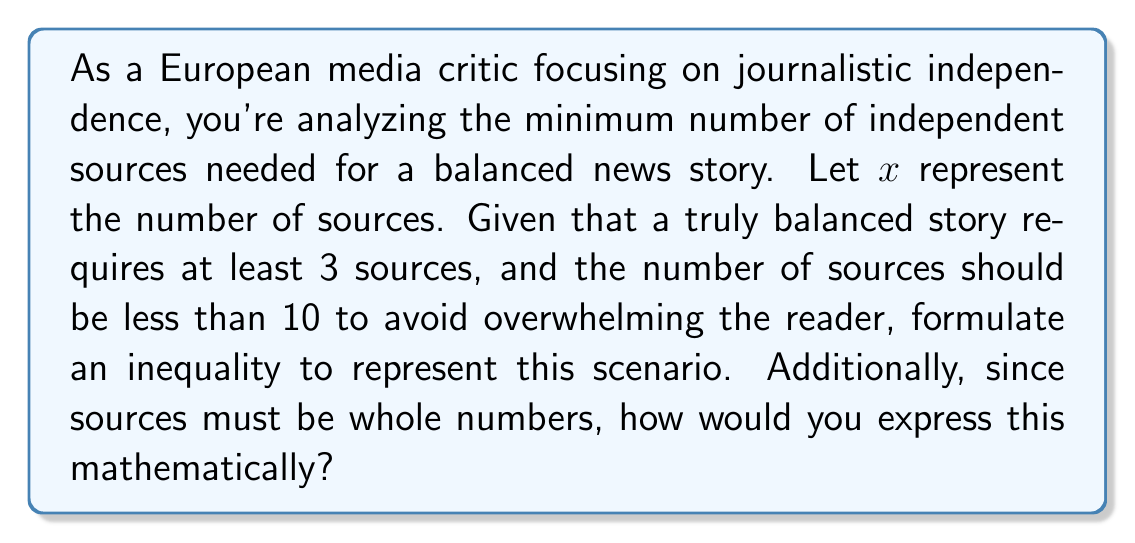Help me with this question. To solve this problem, we need to break it down into steps:

1. Establish the lower bound:
   The question states that a balanced story requires at least 3 sources. This can be expressed as:
   $$x \geq 3$$

2. Establish the upper bound:
   The number of sources should be less than 10 to avoid overwhelming the reader. This can be expressed as:
   $$x < 10$$

3. Combine the inequalities:
   We can express both conditions in a single compound inequality:
   $$3 \leq x < 10$$

4. Consider the whole number requirement:
   Since sources must be whole numbers, we need to use the floor and ceiling functions to express this. The floor function $\lfloor x \rfloor$ gives the largest integer less than or equal to $x$, while the ceiling function $\lceil x \rceil$ gives the smallest integer greater than or equal to $x$.

   We can express the whole number requirement as:
   $$x = \lfloor x \rfloor = \lceil x \rceil$$

5. Combine all conditions:
   The final inequality, incorporating all conditions, can be expressed as:
   $$3 \leq x < 10 \text{ and } x = \lfloor x \rfloor = \lceil x \rceil$$

This inequality represents the minimum number of independent sources needed for a balanced news story, ensuring journalistic independence while not overwhelming the reader, and accounting for the fact that sources must be whole numbers.
Answer: $$3 \leq x < 10 \text{ and } x = \lfloor x \rfloor = \lceil x \rceil$$ 